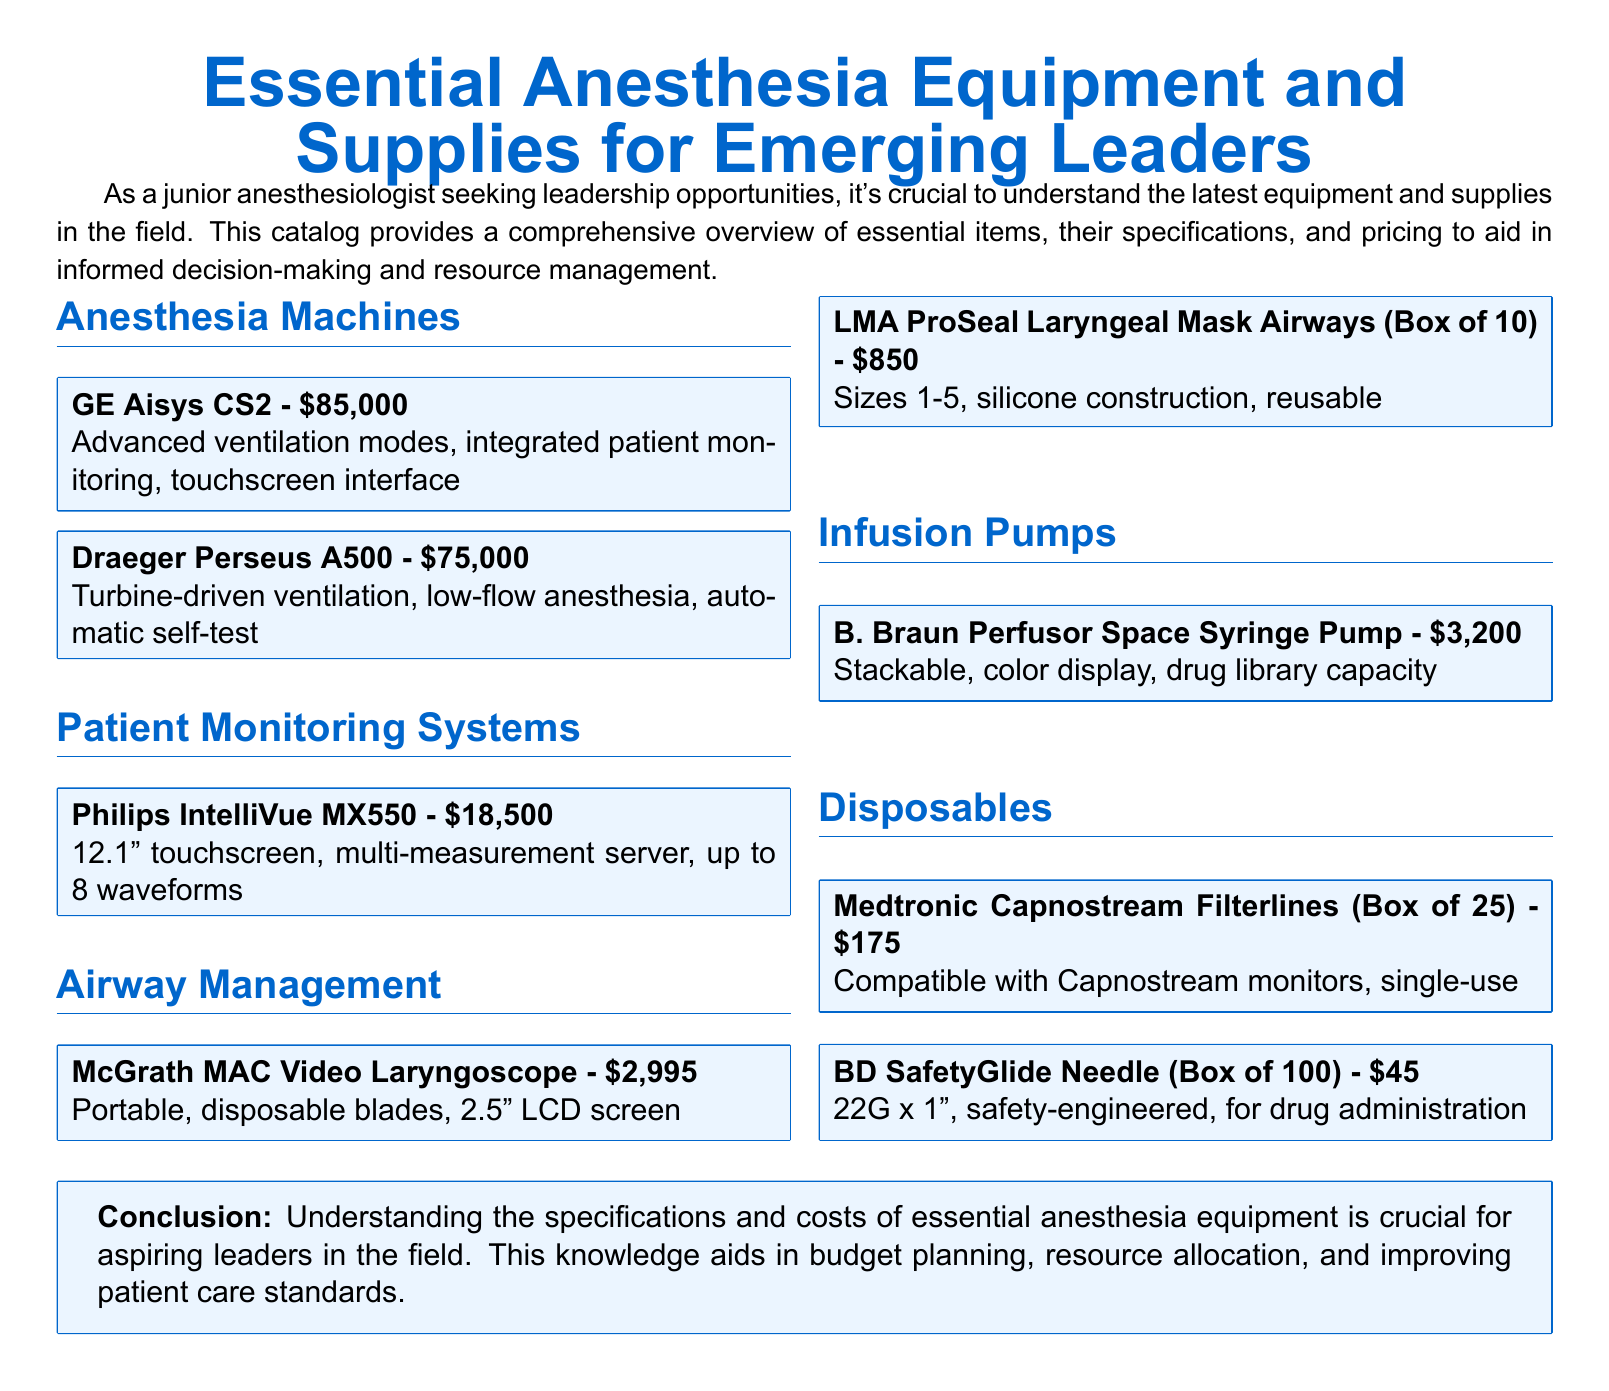What is the price of the GE Aisys CS2? The price of the GE Aisys CS2 is stated in the catalog as $85,000.
Answer: $85,000 How many waveforms can the Philips IntelliVue MX550 monitor display? The catalog specifies that the Philips IntelliVue MX550 can display up to 8 waveforms.
Answer: 8 waveforms What type of display does the B. Braun Perfusor Space Syringe Pump have? The catalog describes the display of the B. Braun Perfusor Space Syringe Pump as color display.
Answer: Color display How many sizes do the LMA ProSeal Laryngeal Mask Airways come in? The catalog states that the LMA ProSeal Laryngeal Mask Airways are available in sizes 1-5, which is 5 sizes.
Answer: 5 sizes What is the box price of Medtronic Capnostream Filterlines? The box price of Medtronic Capnostream Filterlines is given in the catalog as $175.
Answer: $175 Which anesthesia machine is turbine-driven? The Draeger Perseus A500 is identified in the catalog as having turbine-driven ventilation.
Answer: Draeger Perseus A500 What is the purpose of the BD SafetyGlide Needle? The BD SafetyGlide Needle is specifically designed for drug administration.
Answer: Drug administration What type of product is the McGrath MAC Video Laryngoscope? The catalog categorizes the McGrath MAC Video Laryngoscope as a portable airway management device.
Answer: Portable airway management device 